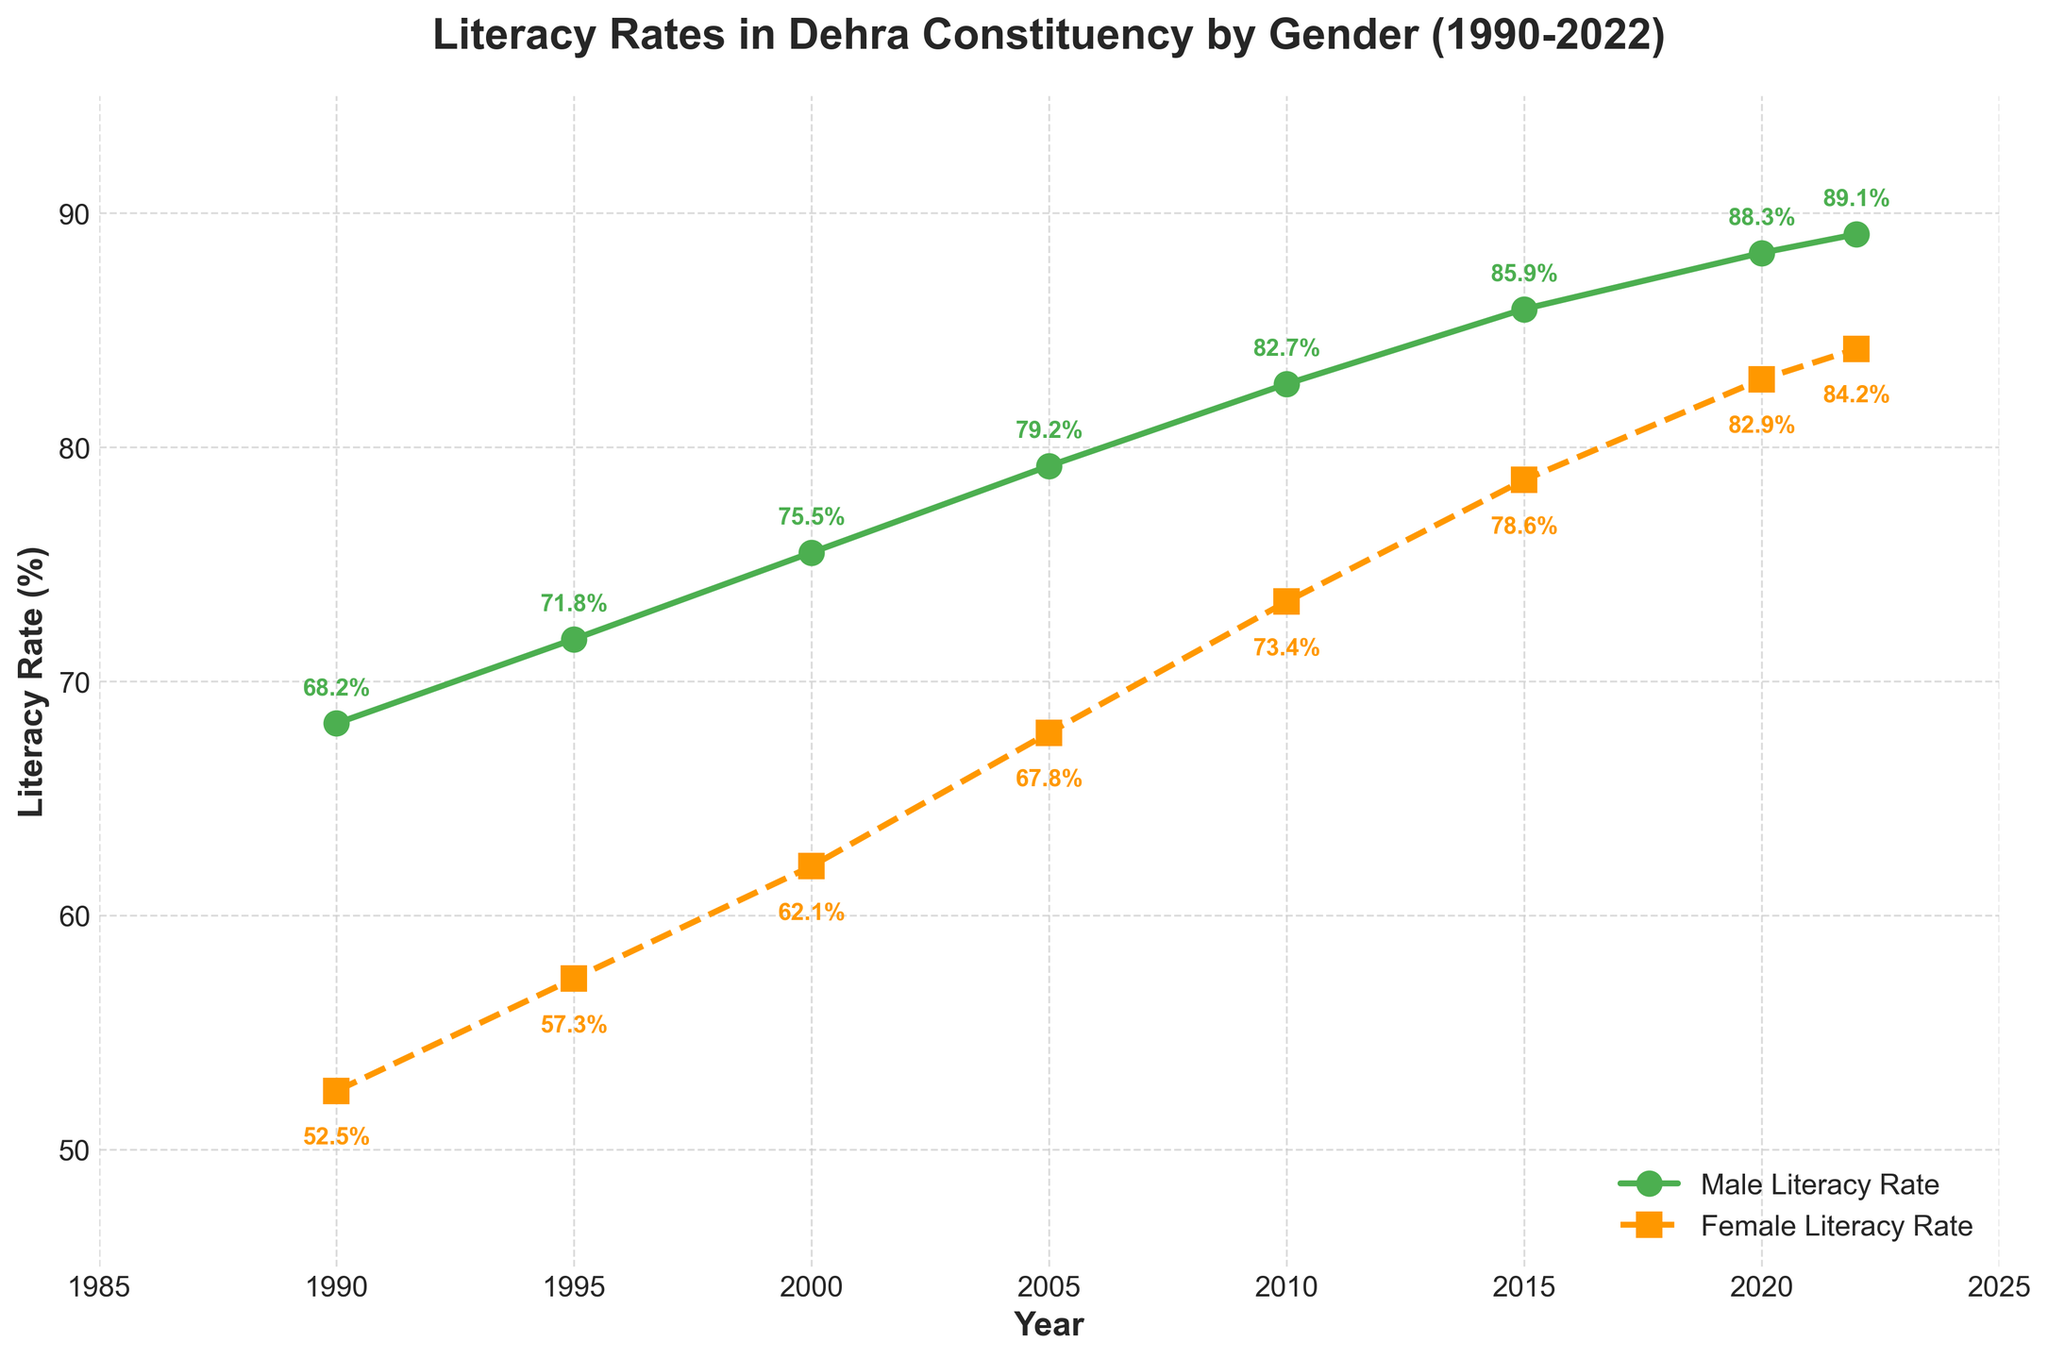When did the male literacy rate first exceed 80%? Refer to the plot and identify the year when the male literacy rate reaches and then surpasses 80%. According to the plot, it happens between 2005 and 2010.
Answer: 2010 Which gender had a higher literacy rate in 1990 and by how much? Compare the male and female literacy rates for 1990. The male literacy rate is 68.2%, while the female literacy rate is 52.5%. Subtract the two rates to find the difference.
Answer: Male by 15.7% What is the average female literacy rate from 1990 to 2022? Calculate the sum of female literacy rates for each year provided: 52.5, 57.3, 62.1, 67.8, 73.4, 78.6, 82.9, 84.2. Then, divide the total by the number of observations (8).
Answer: 69.85% In which year was the difference between male and female literacy rates the smallest? Observe the differences between male and female literacy rates for all years presented in the plot. The difference is visually smallest in 2022.
Answer: 2022 Compare the trend of male and female literacy rates. How have they changed from 1990 to 2022? Examine the slopes of the lines representing male and female literacy rates. Both rates show an upward trend, with male literacy increasing from 68.2% to 89.1% and female literacy increasing from 52.5% to 84.2%. The trend indicates substantial improvement in both genders.
Answer: Both increased, male from 68.2% to 89.1%, female from 52.5% to 84.2% In 2015, how much higher was the male literacy rate compared to the female literacy rate? Check the literacy rates for both genders in 2015. The male literacy rate is 85.9% and the female literacy rate is 78.6%. Subtract the female rate from the male rate.
Answer: 7.3% What is the total increase in male literacy rate from 1990 to 2022? Subtract the male literacy rate in 1990 from the male literacy rate in 2022. The calculation is 89.1% - 68.2%.
Answer: 20.9% Which year showed the largest increase in female literacy rate compared to the previous recorded year? Look at the increments in female literacy rate between each recorded year. The largest increase occurred between 2000 and 2005 (from 62.1% to 67.8%).
Answer: 2005 What is the male to female literacy rate ratio in 2000? Divide the male literacy rate by the female literacy rate for the year 2000. The male rate is 75.5% and the female rate is 62.1%.
Answer: 1.22 By what percentage did the female literacy rate increase from 1990 to 2020? Subtract the female literacy rate in 1990 from the female literacy rate in 2020, then divide the result by the 1990 figure, and multiply by 100 to get the percentage increase. ((82.9 - 52.5) / 52.5) * 100.
Answer: 57.8% 